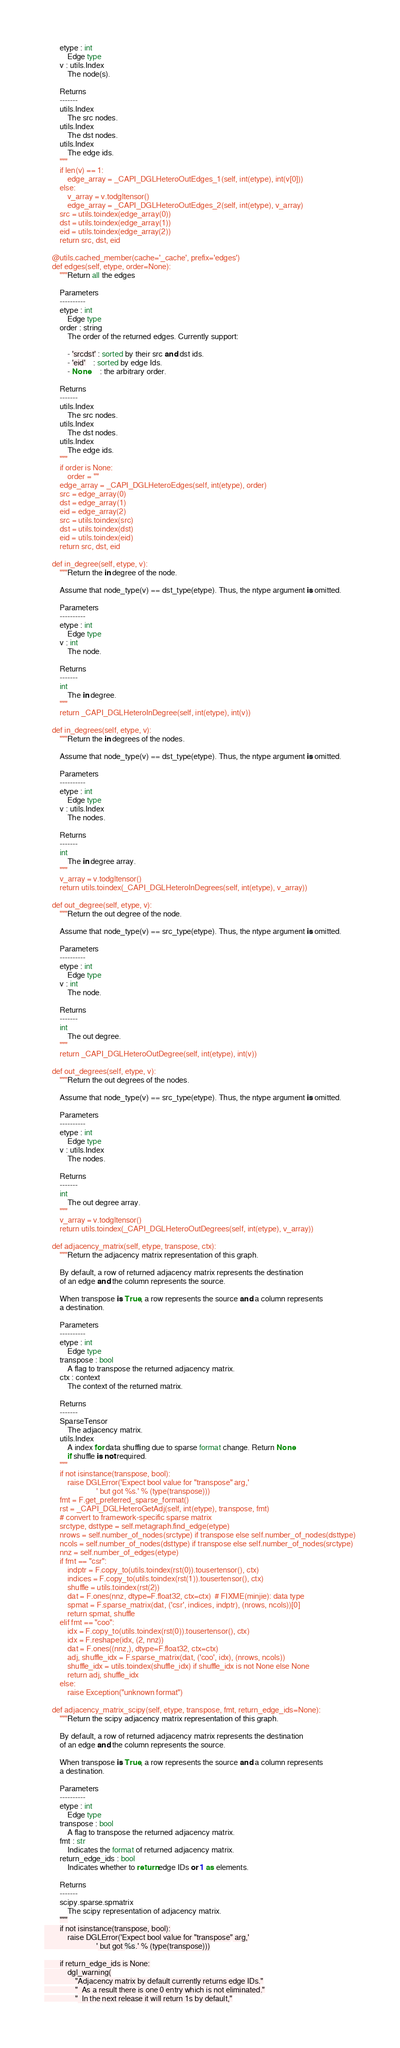<code> <loc_0><loc_0><loc_500><loc_500><_Python_>        etype : int
            Edge type
        v : utils.Index
            The node(s).

        Returns
        -------
        utils.Index
            The src nodes.
        utils.Index
            The dst nodes.
        utils.Index
            The edge ids.
        """
        if len(v) == 1:
            edge_array = _CAPI_DGLHeteroOutEdges_1(self, int(etype), int(v[0]))
        else:
            v_array = v.todgltensor()
            edge_array = _CAPI_DGLHeteroOutEdges_2(self, int(etype), v_array)
        src = utils.toindex(edge_array(0))
        dst = utils.toindex(edge_array(1))
        eid = utils.toindex(edge_array(2))
        return src, dst, eid

    @utils.cached_member(cache='_cache', prefix='edges')
    def edges(self, etype, order=None):
        """Return all the edges

        Parameters
        ----------
        etype : int
            Edge type
        order : string
            The order of the returned edges. Currently support:

            - 'srcdst' : sorted by their src and dst ids.
            - 'eid'    : sorted by edge Ids.
            - None     : the arbitrary order.

        Returns
        -------
        utils.Index
            The src nodes.
        utils.Index
            The dst nodes.
        utils.Index
            The edge ids.
        """
        if order is None:
            order = ""
        edge_array = _CAPI_DGLHeteroEdges(self, int(etype), order)
        src = edge_array(0)
        dst = edge_array(1)
        eid = edge_array(2)
        src = utils.toindex(src)
        dst = utils.toindex(dst)
        eid = utils.toindex(eid)
        return src, dst, eid

    def in_degree(self, etype, v):
        """Return the in degree of the node.

        Assume that node_type(v) == dst_type(etype). Thus, the ntype argument is omitted.

        Parameters
        ----------
        etype : int
            Edge type
        v : int
            The node.

        Returns
        -------
        int
            The in degree.
        """
        return _CAPI_DGLHeteroInDegree(self, int(etype), int(v))

    def in_degrees(self, etype, v):
        """Return the in degrees of the nodes.

        Assume that node_type(v) == dst_type(etype). Thus, the ntype argument is omitted.

        Parameters
        ----------
        etype : int
            Edge type
        v : utils.Index
            The nodes.

        Returns
        -------
        int
            The in degree array.
        """
        v_array = v.todgltensor()
        return utils.toindex(_CAPI_DGLHeteroInDegrees(self, int(etype), v_array))

    def out_degree(self, etype, v):
        """Return the out degree of the node.

        Assume that node_type(v) == src_type(etype). Thus, the ntype argument is omitted.

        Parameters
        ----------
        etype : int
            Edge type
        v : int
            The node.

        Returns
        -------
        int
            The out degree.
        """
        return _CAPI_DGLHeteroOutDegree(self, int(etype), int(v))

    def out_degrees(self, etype, v):
        """Return the out degrees of the nodes.

        Assume that node_type(v) == src_type(etype). Thus, the ntype argument is omitted.

        Parameters
        ----------
        etype : int
            Edge type
        v : utils.Index
            The nodes.

        Returns
        -------
        int
            The out degree array.
        """
        v_array = v.todgltensor()
        return utils.toindex(_CAPI_DGLHeteroOutDegrees(self, int(etype), v_array))

    def adjacency_matrix(self, etype, transpose, ctx):
        """Return the adjacency matrix representation of this graph.

        By default, a row of returned adjacency matrix represents the destination
        of an edge and the column represents the source.

        When transpose is True, a row represents the source and a column represents
        a destination.

        Parameters
        ----------
        etype : int
            Edge type
        transpose : bool
            A flag to transpose the returned adjacency matrix.
        ctx : context
            The context of the returned matrix.

        Returns
        -------
        SparseTensor
            The adjacency matrix.
        utils.Index
            A index for data shuffling due to sparse format change. Return None
            if shuffle is not required.
        """
        if not isinstance(transpose, bool):
            raise DGLError('Expect bool value for "transpose" arg,'
                           ' but got %s.' % (type(transpose)))
        fmt = F.get_preferred_sparse_format()
        rst = _CAPI_DGLHeteroGetAdj(self, int(etype), transpose, fmt)
        # convert to framework-specific sparse matrix
        srctype, dsttype = self.metagraph.find_edge(etype)
        nrows = self.number_of_nodes(srctype) if transpose else self.number_of_nodes(dsttype)
        ncols = self.number_of_nodes(dsttype) if transpose else self.number_of_nodes(srctype)
        nnz = self.number_of_edges(etype)
        if fmt == "csr":
            indptr = F.copy_to(utils.toindex(rst(0)).tousertensor(), ctx)
            indices = F.copy_to(utils.toindex(rst(1)).tousertensor(), ctx)
            shuffle = utils.toindex(rst(2))
            dat = F.ones(nnz, dtype=F.float32, ctx=ctx)  # FIXME(minjie): data type
            spmat = F.sparse_matrix(dat, ('csr', indices, indptr), (nrows, ncols))[0]
            return spmat, shuffle
        elif fmt == "coo":
            idx = F.copy_to(utils.toindex(rst(0)).tousertensor(), ctx)
            idx = F.reshape(idx, (2, nnz))
            dat = F.ones((nnz,), dtype=F.float32, ctx=ctx)
            adj, shuffle_idx = F.sparse_matrix(dat, ('coo', idx), (nrows, ncols))
            shuffle_idx = utils.toindex(shuffle_idx) if shuffle_idx is not None else None
            return adj, shuffle_idx
        else:
            raise Exception("unknown format")

    def adjacency_matrix_scipy(self, etype, transpose, fmt, return_edge_ids=None):
        """Return the scipy adjacency matrix representation of this graph.

        By default, a row of returned adjacency matrix represents the destination
        of an edge and the column represents the source.

        When transpose is True, a row represents the source and a column represents
        a destination.

        Parameters
        ----------
        etype : int
            Edge type
        transpose : bool
            A flag to transpose the returned adjacency matrix.
        fmt : str
            Indicates the format of returned adjacency matrix.
        return_edge_ids : bool
            Indicates whether to return edge IDs or 1 as elements.

        Returns
        -------
        scipy.sparse.spmatrix
            The scipy representation of adjacency matrix.
        """
        if not isinstance(transpose, bool):
            raise DGLError('Expect bool value for "transpose" arg,'
                           ' but got %s.' % (type(transpose)))

        if return_edge_ids is None:
            dgl_warning(
                "Adjacency matrix by default currently returns edge IDs."
                "  As a result there is one 0 entry which is not eliminated."
                "  In the next release it will return 1s by default,"</code> 